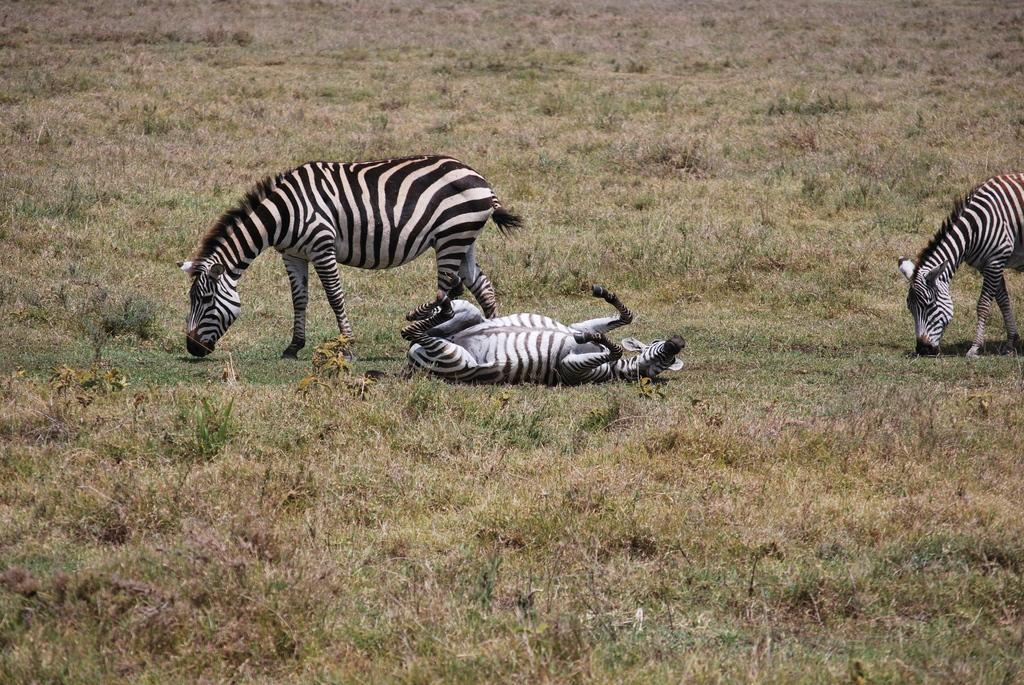How many zebras are present in the image? There are three zebras in the image. What are the positions of the zebras in the image? Two of the zebras are standing, and one is lying down. What type of vegetation can be seen on the ground in the image? There is grass on the ground in the image. What type of swing can be seen in the image? There is no swing present in the image; it features three zebras and grass on the ground. Can you describe the mist in the image? There is no mist present in the image. 